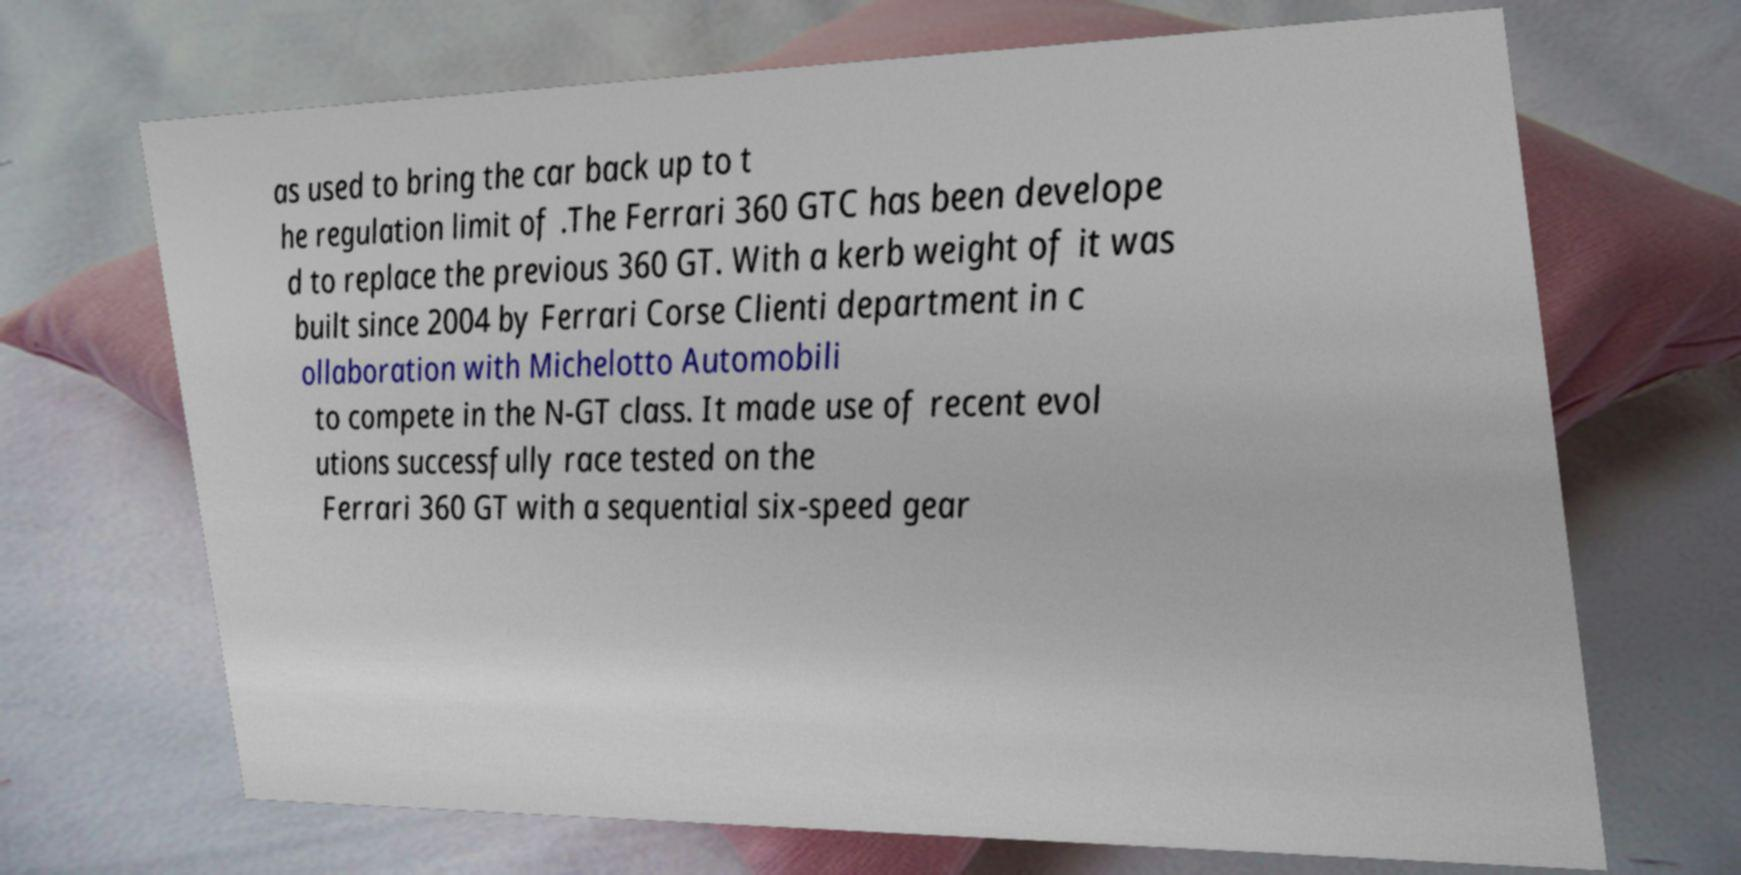Could you assist in decoding the text presented in this image and type it out clearly? as used to bring the car back up to t he regulation limit of .The Ferrari 360 GTC has been develope d to replace the previous 360 GT. With a kerb weight of it was built since 2004 by Ferrari Corse Clienti department in c ollaboration with Michelotto Automobili to compete in the N-GT class. It made use of recent evol utions successfully race tested on the Ferrari 360 GT with a sequential six-speed gear 